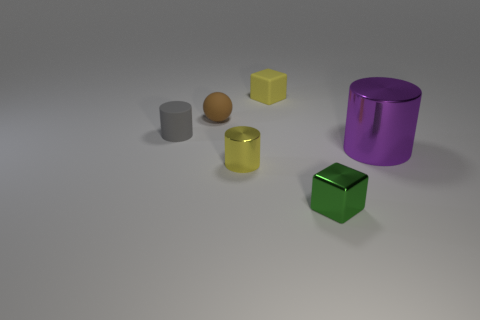There is a small green thing; does it have the same shape as the yellow object in front of the yellow matte object?
Provide a succinct answer. No. There is a tiny cylinder that is in front of the tiny object that is left of the small brown ball; what is it made of?
Keep it short and to the point. Metal. Are there an equal number of metal objects in front of the green cube and small green metallic things?
Ensure brevity in your answer.  No. Are there any other things that have the same material as the gray cylinder?
Your response must be concise. Yes. Does the small matte thing that is in front of the small brown rubber sphere have the same color as the metallic cylinder right of the tiny yellow cube?
Provide a succinct answer. No. What number of cylinders are both behind the big metal thing and in front of the gray rubber cylinder?
Your response must be concise. 0. Is the number of big purple matte objects the same as the number of small cubes?
Give a very brief answer. No. How many other objects are the same shape as the tiny yellow shiny object?
Keep it short and to the point. 2. Is the number of tiny objects behind the tiny yellow metal cylinder greater than the number of large yellow metallic cylinders?
Keep it short and to the point. Yes. What is the color of the tiny matte thing in front of the brown matte thing?
Provide a succinct answer. Gray. 